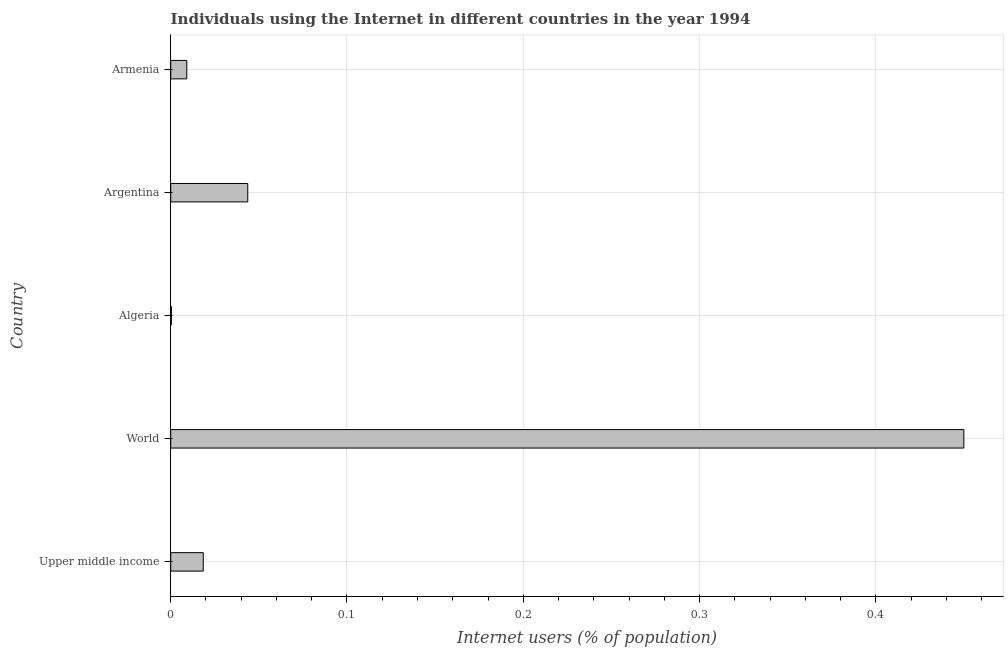Does the graph contain any zero values?
Offer a terse response. No. Does the graph contain grids?
Keep it short and to the point. Yes. What is the title of the graph?
Your answer should be compact. Individuals using the Internet in different countries in the year 1994. What is the label or title of the X-axis?
Your answer should be compact. Internet users (% of population). What is the label or title of the Y-axis?
Give a very brief answer. Country. What is the number of internet users in Argentina?
Provide a short and direct response. 0.04. Across all countries, what is the maximum number of internet users?
Provide a succinct answer. 0.45. Across all countries, what is the minimum number of internet users?
Offer a terse response. 0. In which country was the number of internet users maximum?
Provide a succinct answer. World. In which country was the number of internet users minimum?
Provide a succinct answer. Algeria. What is the sum of the number of internet users?
Make the answer very short. 0.52. What is the difference between the number of internet users in Upper middle income and World?
Your answer should be compact. -0.43. What is the average number of internet users per country?
Provide a succinct answer. 0.1. What is the median number of internet users?
Provide a succinct answer. 0.02. What is the ratio of the number of internet users in Algeria to that in Upper middle income?
Offer a very short reply. 0.02. Is the number of internet users in Argentina less than that in Upper middle income?
Keep it short and to the point. No. What is the difference between the highest and the second highest number of internet users?
Offer a very short reply. 0.41. What is the difference between the highest and the lowest number of internet users?
Ensure brevity in your answer.  0.45. Are all the bars in the graph horizontal?
Your response must be concise. Yes. How many countries are there in the graph?
Keep it short and to the point. 5. What is the difference between two consecutive major ticks on the X-axis?
Offer a very short reply. 0.1. What is the Internet users (% of population) in Upper middle income?
Offer a terse response. 0.02. What is the Internet users (% of population) in World?
Your answer should be very brief. 0.45. What is the Internet users (% of population) of Algeria?
Your answer should be compact. 0. What is the Internet users (% of population) in Argentina?
Give a very brief answer. 0.04. What is the Internet users (% of population) in Armenia?
Offer a very short reply. 0.01. What is the difference between the Internet users (% of population) in Upper middle income and World?
Keep it short and to the point. -0.43. What is the difference between the Internet users (% of population) in Upper middle income and Algeria?
Make the answer very short. 0.02. What is the difference between the Internet users (% of population) in Upper middle income and Argentina?
Give a very brief answer. -0.03. What is the difference between the Internet users (% of population) in Upper middle income and Armenia?
Ensure brevity in your answer.  0.01. What is the difference between the Internet users (% of population) in World and Algeria?
Offer a very short reply. 0.45. What is the difference between the Internet users (% of population) in World and Argentina?
Offer a terse response. 0.41. What is the difference between the Internet users (% of population) in World and Armenia?
Your answer should be compact. 0.44. What is the difference between the Internet users (% of population) in Algeria and Argentina?
Keep it short and to the point. -0.04. What is the difference between the Internet users (% of population) in Algeria and Armenia?
Offer a very short reply. -0.01. What is the difference between the Internet users (% of population) in Argentina and Armenia?
Provide a succinct answer. 0.03. What is the ratio of the Internet users (% of population) in Upper middle income to that in World?
Offer a very short reply. 0.04. What is the ratio of the Internet users (% of population) in Upper middle income to that in Algeria?
Offer a very short reply. 51.19. What is the ratio of the Internet users (% of population) in Upper middle income to that in Argentina?
Your response must be concise. 0.42. What is the ratio of the Internet users (% of population) in Upper middle income to that in Armenia?
Ensure brevity in your answer.  2.02. What is the ratio of the Internet users (% of population) in World to that in Algeria?
Offer a terse response. 1247.55. What is the ratio of the Internet users (% of population) in World to that in Argentina?
Your answer should be compact. 10.29. What is the ratio of the Internet users (% of population) in World to that in Armenia?
Your answer should be compact. 49.35. What is the ratio of the Internet users (% of population) in Algeria to that in Argentina?
Provide a short and direct response. 0.01. What is the ratio of the Internet users (% of population) in Algeria to that in Armenia?
Your response must be concise. 0.04. What is the ratio of the Internet users (% of population) in Argentina to that in Armenia?
Make the answer very short. 4.79. 